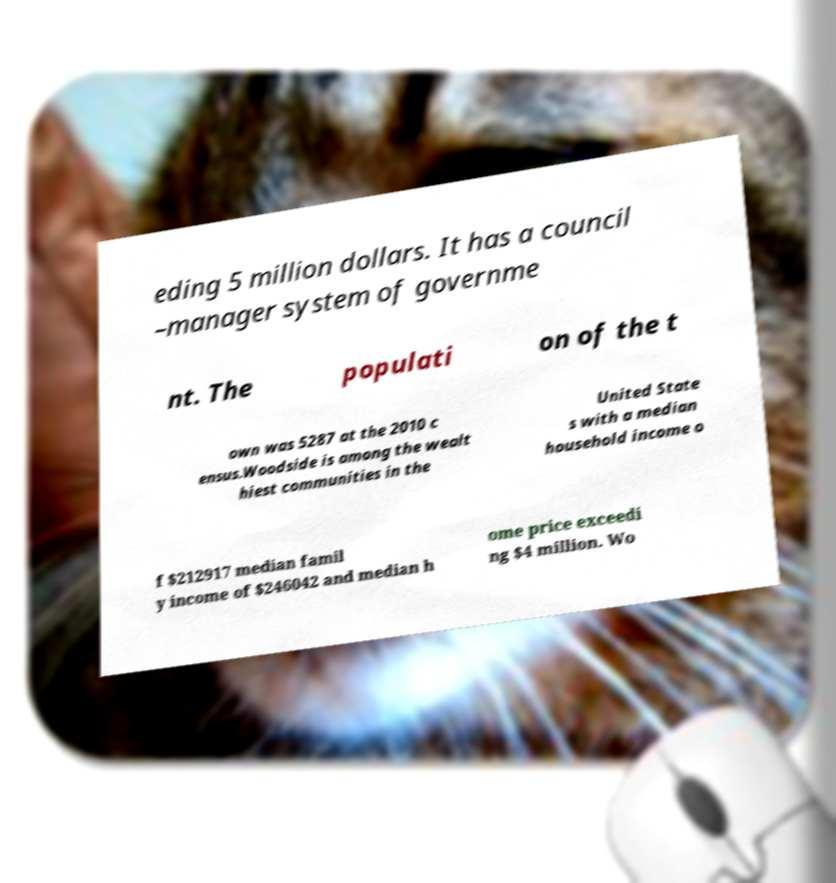Please identify and transcribe the text found in this image. eding 5 million dollars. It has a council –manager system of governme nt. The populati on of the t own was 5287 at the 2010 c ensus.Woodside is among the wealt hiest communities in the United State s with a median household income o f $212917 median famil y income of $246042 and median h ome price exceedi ng $4 million. Wo 